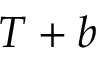<formula> <loc_0><loc_0><loc_500><loc_500>T + b</formula> 